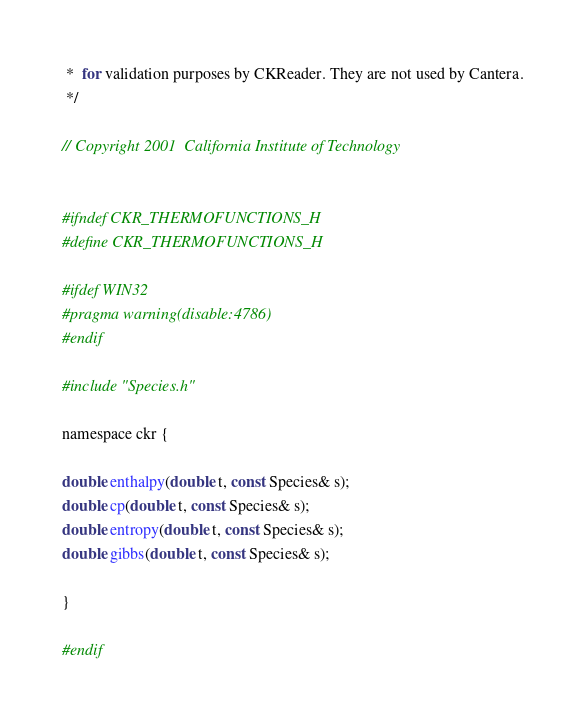Convert code to text. <code><loc_0><loc_0><loc_500><loc_500><_C_> *  for validation purposes by CKReader. They are not used by Cantera.
 */

// Copyright 2001  California Institute of Technology


#ifndef CKR_THERMOFUNCTIONS_H
#define CKR_THERMOFUNCTIONS_H

#ifdef WIN32
#pragma warning(disable:4786)
#endif

#include "Species.h"

namespace ckr {

double enthalpy(double t, const Species& s);
double cp(double t, const Species& s);
double entropy(double t, const Species& s);
double gibbs(double t, const Species& s);

}

#endif

</code> 